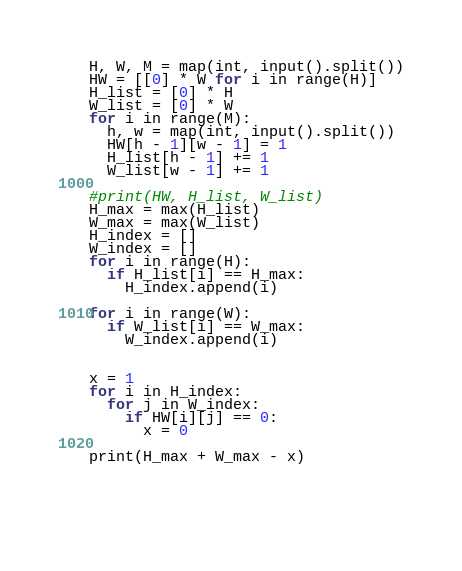<code> <loc_0><loc_0><loc_500><loc_500><_Python_>H, W, M = map(int, input().split())
HW = [[0] * W for i in range(H)]
H_list = [0] * H
W_list = [0] * W
for i in range(M):
  h, w = map(int, input().split()) 
  HW[h - 1][w - 1] = 1
  H_list[h - 1] += 1
  W_list[w - 1] += 1
  
#print(HW, H_list, W_list)  
H_max = max(H_list)
W_max = max(W_list)
H_index = []
W_index = []
for i in range(H):
  if H_list[i] == H_max:
    H_index.append(i)
    
for i in range(W):
  if W_list[i] == W_max:
    W_index.append(i)
    

x = 1
for i in H_index:
  for j in W_index:
    if HW[i][j] == 0:
      x = 0
      
print(H_max + W_max - x)      
    
    
    
    




</code> 